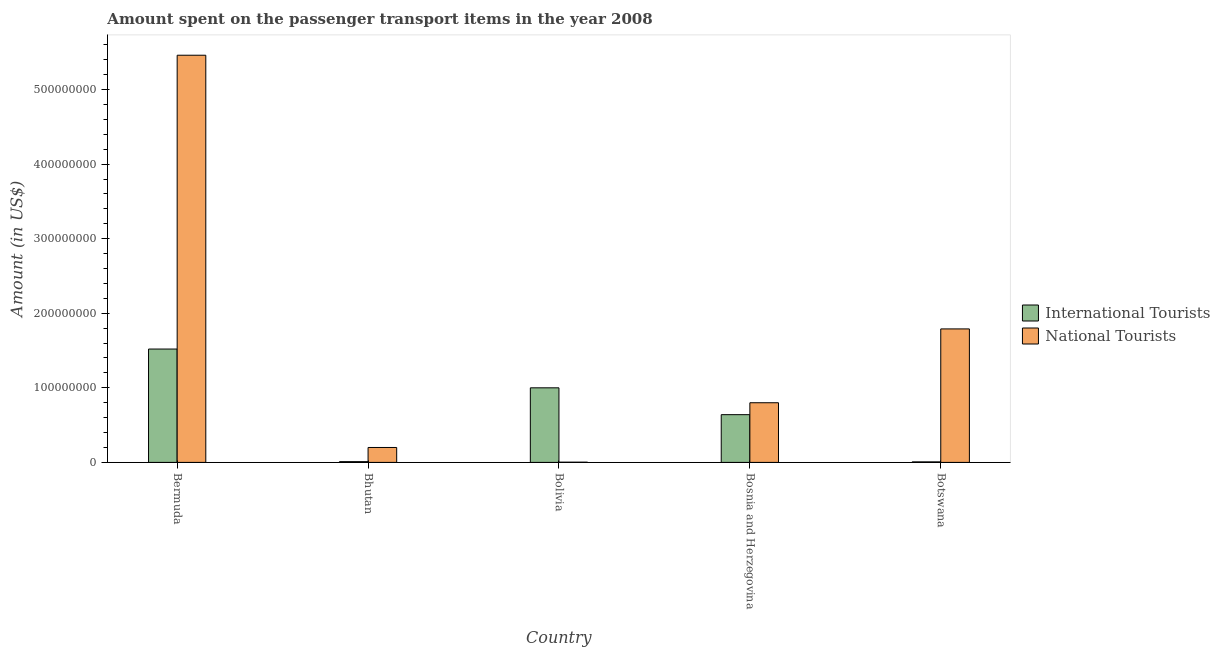How many groups of bars are there?
Your answer should be very brief. 5. Are the number of bars per tick equal to the number of legend labels?
Your answer should be compact. Yes. Are the number of bars on each tick of the X-axis equal?
Your response must be concise. Yes. What is the label of the 2nd group of bars from the left?
Your answer should be very brief. Bhutan. In how many cases, is the number of bars for a given country not equal to the number of legend labels?
Offer a very short reply. 0. What is the amount spent on transport items of international tourists in Bolivia?
Offer a terse response. 1.00e+08. Across all countries, what is the maximum amount spent on transport items of international tourists?
Your answer should be very brief. 1.52e+08. In which country was the amount spent on transport items of international tourists maximum?
Your response must be concise. Bermuda. In which country was the amount spent on transport items of international tourists minimum?
Your response must be concise. Botswana. What is the total amount spent on transport items of national tourists in the graph?
Provide a succinct answer. 8.25e+08. What is the difference between the amount spent on transport items of international tourists in Bermuda and that in Bosnia and Herzegovina?
Offer a terse response. 8.80e+07. What is the difference between the amount spent on transport items of international tourists in Botswana and the amount spent on transport items of national tourists in Bhutan?
Offer a terse response. -1.93e+07. What is the average amount spent on transport items of international tourists per country?
Keep it short and to the point. 6.35e+07. What is the difference between the amount spent on transport items of international tourists and amount spent on transport items of national tourists in Botswana?
Keep it short and to the point. -1.78e+08. In how many countries, is the amount spent on transport items of national tourists greater than 520000000 US$?
Your response must be concise. 1. What is the ratio of the amount spent on transport items of national tourists in Bermuda to that in Bosnia and Herzegovina?
Your response must be concise. 6.83. What is the difference between the highest and the second highest amount spent on transport items of international tourists?
Keep it short and to the point. 5.20e+07. What is the difference between the highest and the lowest amount spent on transport items of international tourists?
Provide a short and direct response. 1.51e+08. In how many countries, is the amount spent on transport items of international tourists greater than the average amount spent on transport items of international tourists taken over all countries?
Make the answer very short. 3. Is the sum of the amount spent on transport items of national tourists in Bermuda and Bosnia and Herzegovina greater than the maximum amount spent on transport items of international tourists across all countries?
Your answer should be very brief. Yes. What does the 1st bar from the left in Bhutan represents?
Keep it short and to the point. International Tourists. What does the 1st bar from the right in Bhutan represents?
Ensure brevity in your answer.  National Tourists. How many bars are there?
Give a very brief answer. 10. Are all the bars in the graph horizontal?
Make the answer very short. No. How many countries are there in the graph?
Keep it short and to the point. 5. Are the values on the major ticks of Y-axis written in scientific E-notation?
Provide a succinct answer. No. Does the graph contain any zero values?
Ensure brevity in your answer.  No. Does the graph contain grids?
Ensure brevity in your answer.  No. How are the legend labels stacked?
Provide a succinct answer. Vertical. What is the title of the graph?
Give a very brief answer. Amount spent on the passenger transport items in the year 2008. What is the Amount (in US$) in International Tourists in Bermuda?
Your answer should be compact. 1.52e+08. What is the Amount (in US$) in National Tourists in Bermuda?
Make the answer very short. 5.46e+08. What is the Amount (in US$) in National Tourists in Bhutan?
Provide a succinct answer. 2.00e+07. What is the Amount (in US$) in International Tourists in Bolivia?
Provide a short and direct response. 1.00e+08. What is the Amount (in US$) of International Tourists in Bosnia and Herzegovina?
Provide a succinct answer. 6.40e+07. What is the Amount (in US$) in National Tourists in Bosnia and Herzegovina?
Make the answer very short. 8.00e+07. What is the Amount (in US$) of International Tourists in Botswana?
Provide a succinct answer. 7.00e+05. What is the Amount (in US$) of National Tourists in Botswana?
Ensure brevity in your answer.  1.79e+08. Across all countries, what is the maximum Amount (in US$) of International Tourists?
Offer a terse response. 1.52e+08. Across all countries, what is the maximum Amount (in US$) of National Tourists?
Give a very brief answer. 5.46e+08. What is the total Amount (in US$) in International Tourists in the graph?
Your response must be concise. 3.18e+08. What is the total Amount (in US$) in National Tourists in the graph?
Your answer should be very brief. 8.25e+08. What is the difference between the Amount (in US$) in International Tourists in Bermuda and that in Bhutan?
Your response must be concise. 1.51e+08. What is the difference between the Amount (in US$) in National Tourists in Bermuda and that in Bhutan?
Keep it short and to the point. 5.26e+08. What is the difference between the Amount (in US$) in International Tourists in Bermuda and that in Bolivia?
Your answer should be compact. 5.20e+07. What is the difference between the Amount (in US$) in National Tourists in Bermuda and that in Bolivia?
Offer a terse response. 5.46e+08. What is the difference between the Amount (in US$) of International Tourists in Bermuda and that in Bosnia and Herzegovina?
Make the answer very short. 8.80e+07. What is the difference between the Amount (in US$) of National Tourists in Bermuda and that in Bosnia and Herzegovina?
Offer a very short reply. 4.66e+08. What is the difference between the Amount (in US$) of International Tourists in Bermuda and that in Botswana?
Provide a succinct answer. 1.51e+08. What is the difference between the Amount (in US$) in National Tourists in Bermuda and that in Botswana?
Keep it short and to the point. 3.67e+08. What is the difference between the Amount (in US$) of International Tourists in Bhutan and that in Bolivia?
Your answer should be compact. -9.90e+07. What is the difference between the Amount (in US$) in National Tourists in Bhutan and that in Bolivia?
Your answer should be compact. 1.97e+07. What is the difference between the Amount (in US$) of International Tourists in Bhutan and that in Bosnia and Herzegovina?
Provide a short and direct response. -6.30e+07. What is the difference between the Amount (in US$) in National Tourists in Bhutan and that in Bosnia and Herzegovina?
Your response must be concise. -6.00e+07. What is the difference between the Amount (in US$) of International Tourists in Bhutan and that in Botswana?
Offer a very short reply. 3.00e+05. What is the difference between the Amount (in US$) in National Tourists in Bhutan and that in Botswana?
Provide a short and direct response. -1.59e+08. What is the difference between the Amount (in US$) in International Tourists in Bolivia and that in Bosnia and Herzegovina?
Make the answer very short. 3.60e+07. What is the difference between the Amount (in US$) in National Tourists in Bolivia and that in Bosnia and Herzegovina?
Keep it short and to the point. -7.97e+07. What is the difference between the Amount (in US$) of International Tourists in Bolivia and that in Botswana?
Your answer should be compact. 9.93e+07. What is the difference between the Amount (in US$) in National Tourists in Bolivia and that in Botswana?
Offer a very short reply. -1.79e+08. What is the difference between the Amount (in US$) of International Tourists in Bosnia and Herzegovina and that in Botswana?
Your answer should be very brief. 6.33e+07. What is the difference between the Amount (in US$) in National Tourists in Bosnia and Herzegovina and that in Botswana?
Your answer should be compact. -9.90e+07. What is the difference between the Amount (in US$) of International Tourists in Bermuda and the Amount (in US$) of National Tourists in Bhutan?
Your response must be concise. 1.32e+08. What is the difference between the Amount (in US$) in International Tourists in Bermuda and the Amount (in US$) in National Tourists in Bolivia?
Offer a very short reply. 1.52e+08. What is the difference between the Amount (in US$) of International Tourists in Bermuda and the Amount (in US$) of National Tourists in Bosnia and Herzegovina?
Give a very brief answer. 7.20e+07. What is the difference between the Amount (in US$) of International Tourists in Bermuda and the Amount (in US$) of National Tourists in Botswana?
Your answer should be compact. -2.70e+07. What is the difference between the Amount (in US$) of International Tourists in Bhutan and the Amount (in US$) of National Tourists in Bosnia and Herzegovina?
Keep it short and to the point. -7.90e+07. What is the difference between the Amount (in US$) of International Tourists in Bhutan and the Amount (in US$) of National Tourists in Botswana?
Your answer should be compact. -1.78e+08. What is the difference between the Amount (in US$) in International Tourists in Bolivia and the Amount (in US$) in National Tourists in Botswana?
Provide a short and direct response. -7.90e+07. What is the difference between the Amount (in US$) of International Tourists in Bosnia and Herzegovina and the Amount (in US$) of National Tourists in Botswana?
Your answer should be very brief. -1.15e+08. What is the average Amount (in US$) in International Tourists per country?
Your response must be concise. 6.35e+07. What is the average Amount (in US$) of National Tourists per country?
Your response must be concise. 1.65e+08. What is the difference between the Amount (in US$) of International Tourists and Amount (in US$) of National Tourists in Bermuda?
Your answer should be compact. -3.94e+08. What is the difference between the Amount (in US$) of International Tourists and Amount (in US$) of National Tourists in Bhutan?
Make the answer very short. -1.90e+07. What is the difference between the Amount (in US$) in International Tourists and Amount (in US$) in National Tourists in Bolivia?
Make the answer very short. 9.97e+07. What is the difference between the Amount (in US$) in International Tourists and Amount (in US$) in National Tourists in Bosnia and Herzegovina?
Your answer should be compact. -1.60e+07. What is the difference between the Amount (in US$) of International Tourists and Amount (in US$) of National Tourists in Botswana?
Make the answer very short. -1.78e+08. What is the ratio of the Amount (in US$) in International Tourists in Bermuda to that in Bhutan?
Offer a terse response. 152. What is the ratio of the Amount (in US$) in National Tourists in Bermuda to that in Bhutan?
Provide a short and direct response. 27.3. What is the ratio of the Amount (in US$) in International Tourists in Bermuda to that in Bolivia?
Your answer should be compact. 1.52. What is the ratio of the Amount (in US$) of National Tourists in Bermuda to that in Bolivia?
Provide a succinct answer. 1820. What is the ratio of the Amount (in US$) in International Tourists in Bermuda to that in Bosnia and Herzegovina?
Make the answer very short. 2.38. What is the ratio of the Amount (in US$) in National Tourists in Bermuda to that in Bosnia and Herzegovina?
Offer a terse response. 6.83. What is the ratio of the Amount (in US$) in International Tourists in Bermuda to that in Botswana?
Ensure brevity in your answer.  217.14. What is the ratio of the Amount (in US$) in National Tourists in Bermuda to that in Botswana?
Keep it short and to the point. 3.05. What is the ratio of the Amount (in US$) in National Tourists in Bhutan to that in Bolivia?
Offer a very short reply. 66.67. What is the ratio of the Amount (in US$) of International Tourists in Bhutan to that in Bosnia and Herzegovina?
Make the answer very short. 0.02. What is the ratio of the Amount (in US$) of International Tourists in Bhutan to that in Botswana?
Provide a succinct answer. 1.43. What is the ratio of the Amount (in US$) in National Tourists in Bhutan to that in Botswana?
Offer a terse response. 0.11. What is the ratio of the Amount (in US$) of International Tourists in Bolivia to that in Bosnia and Herzegovina?
Provide a short and direct response. 1.56. What is the ratio of the Amount (in US$) in National Tourists in Bolivia to that in Bosnia and Herzegovina?
Your response must be concise. 0. What is the ratio of the Amount (in US$) in International Tourists in Bolivia to that in Botswana?
Keep it short and to the point. 142.86. What is the ratio of the Amount (in US$) of National Tourists in Bolivia to that in Botswana?
Offer a very short reply. 0. What is the ratio of the Amount (in US$) of International Tourists in Bosnia and Herzegovina to that in Botswana?
Your response must be concise. 91.43. What is the ratio of the Amount (in US$) of National Tourists in Bosnia and Herzegovina to that in Botswana?
Offer a very short reply. 0.45. What is the difference between the highest and the second highest Amount (in US$) of International Tourists?
Ensure brevity in your answer.  5.20e+07. What is the difference between the highest and the second highest Amount (in US$) in National Tourists?
Your answer should be very brief. 3.67e+08. What is the difference between the highest and the lowest Amount (in US$) in International Tourists?
Ensure brevity in your answer.  1.51e+08. What is the difference between the highest and the lowest Amount (in US$) of National Tourists?
Your response must be concise. 5.46e+08. 